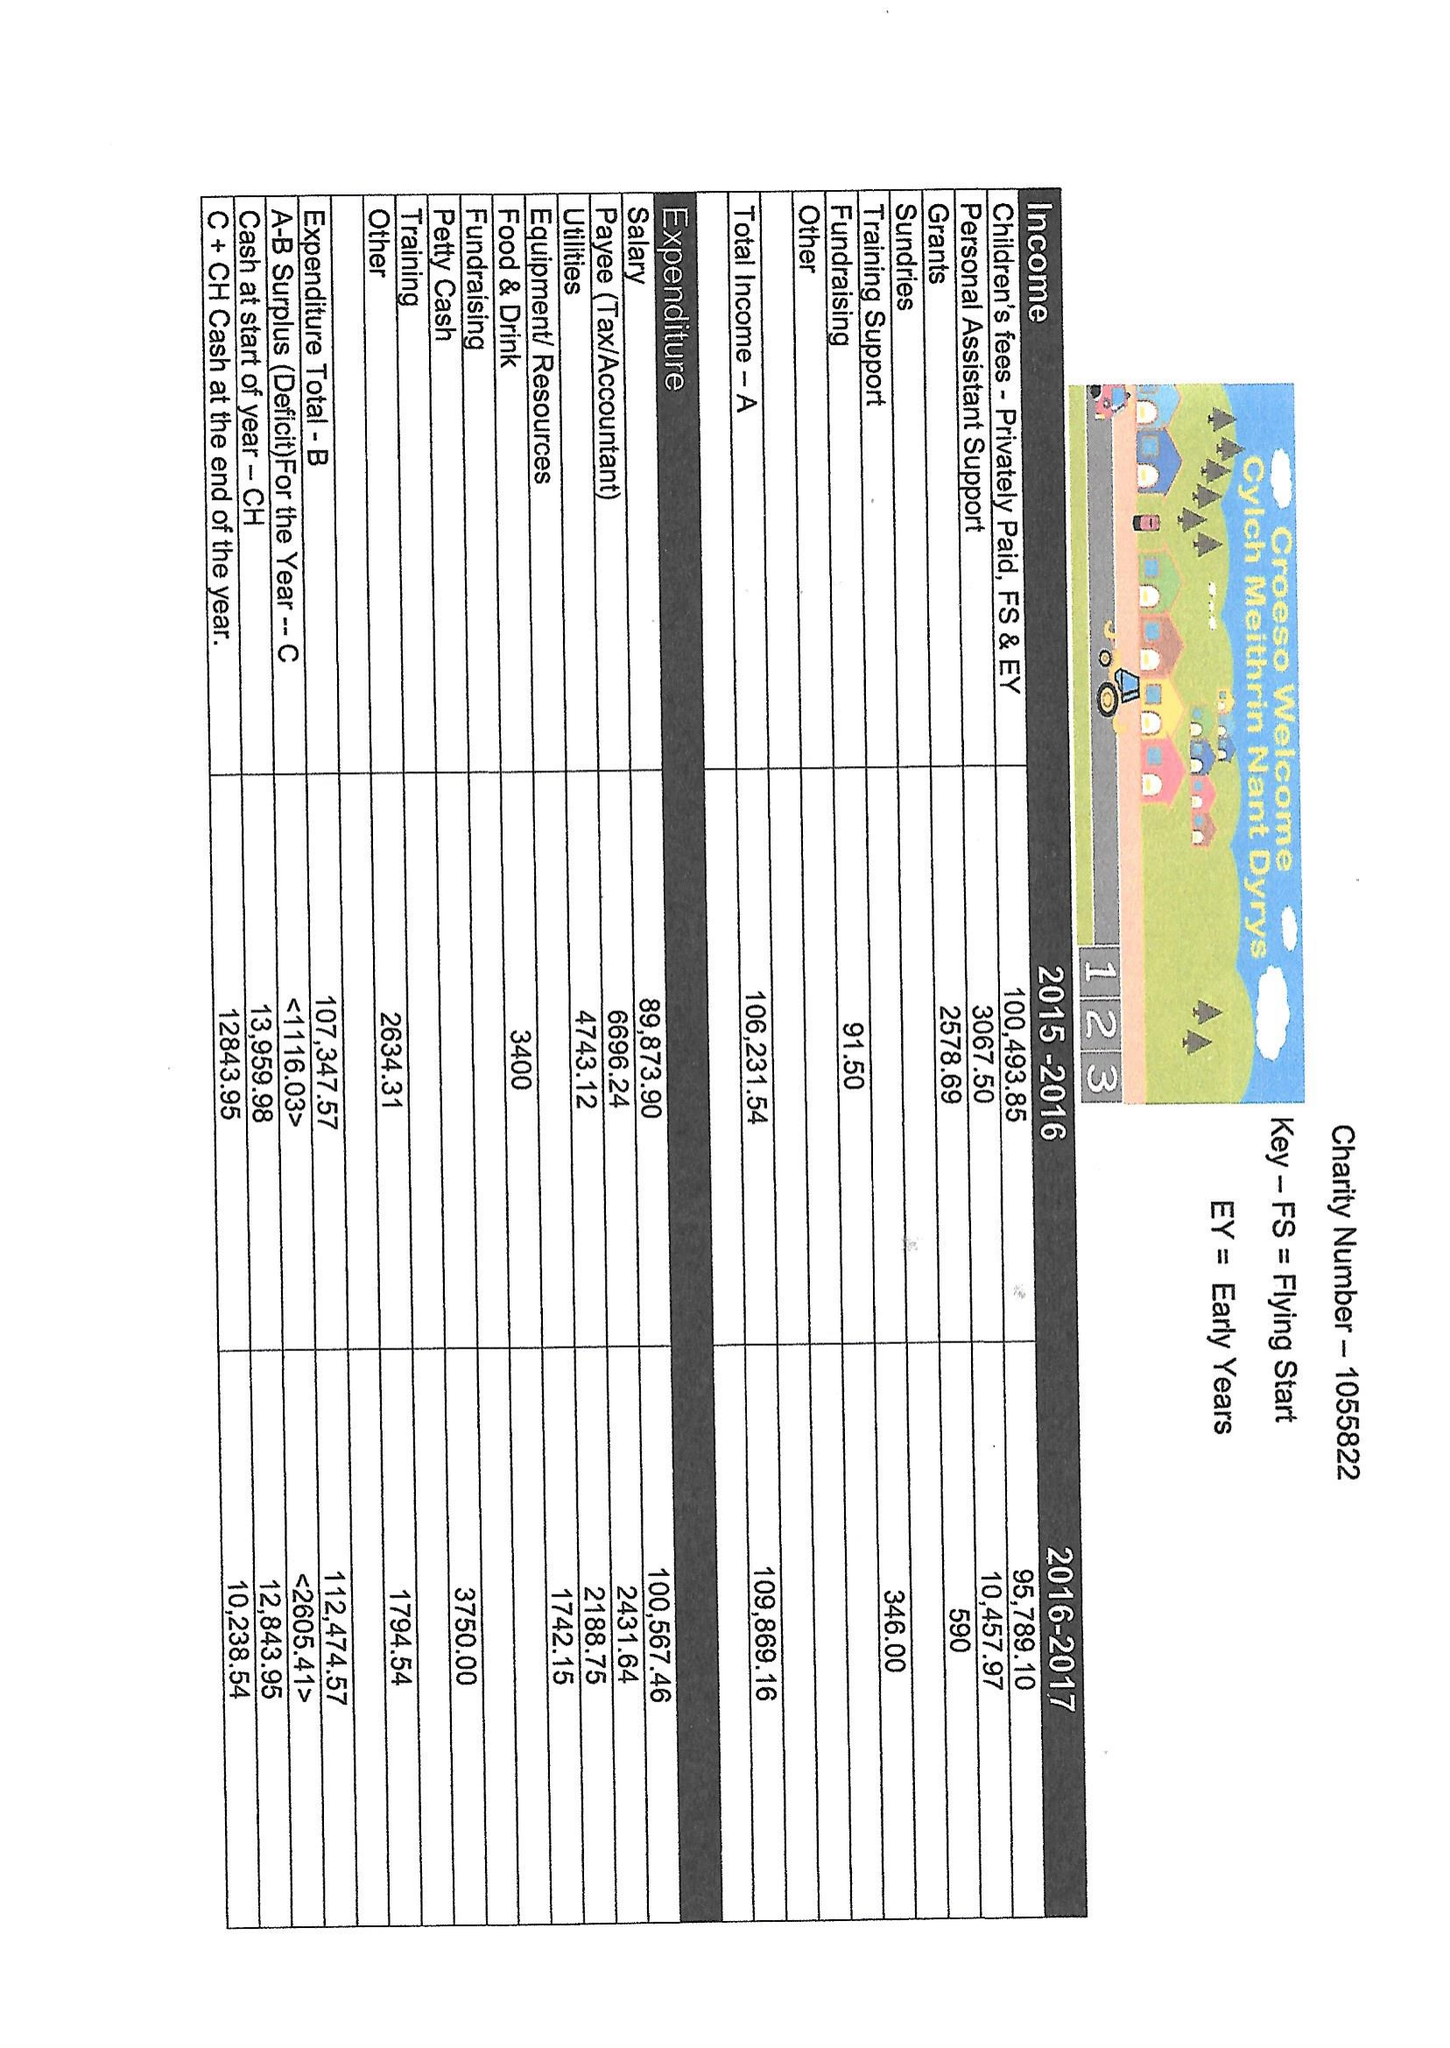What is the value for the address__postcode?
Answer the question using a single word or phrase. CF42 6ED 